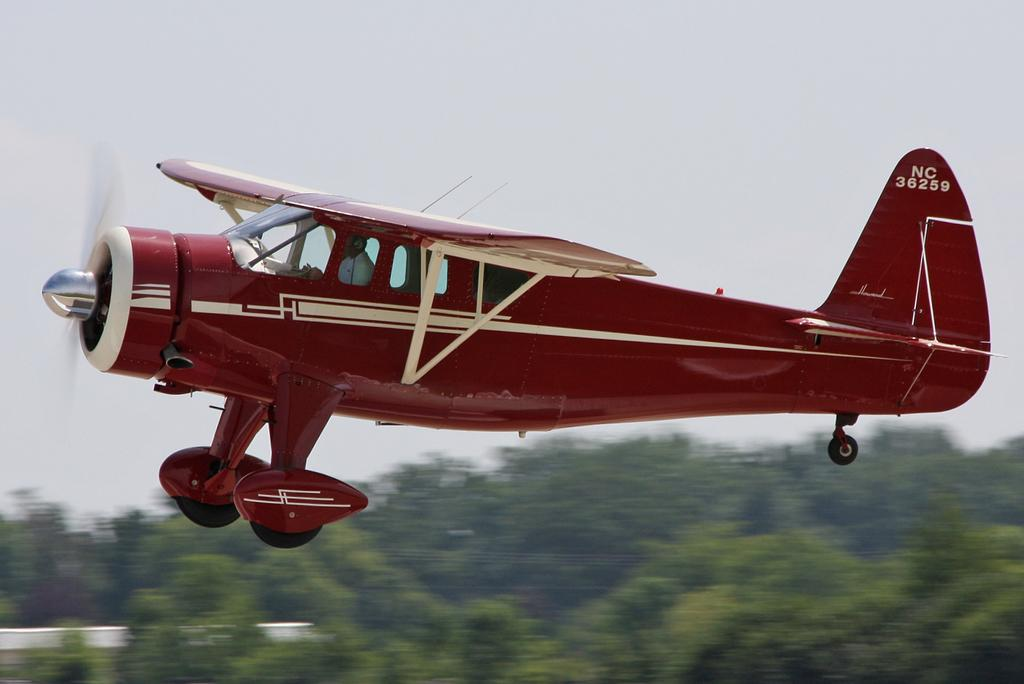What is the main subject of the image? The main subject of the image is an airplane. What is the airplane doing in the image? The airplane is flying in the sky. What color is the background at the bottom of the image? The bottom of the image has a green background. What part of the natural environment is visible in the image? The sky is visible at the top of the image. Can you see a net being used to catch the airplane in the image? There is no net present in the image, and the airplane is flying, not being caught. What type of canvas is covering the airplane in the image? There is no canvas covering the airplane in the image; it is flying in the sky without any visible coverings. 